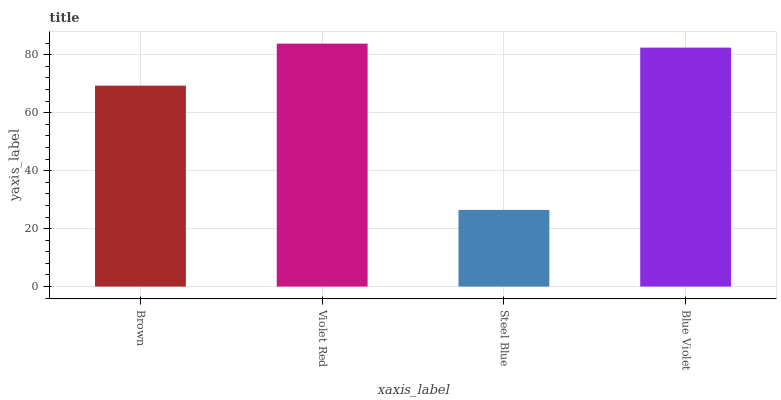Is Steel Blue the minimum?
Answer yes or no. Yes. Is Violet Red the maximum?
Answer yes or no. Yes. Is Violet Red the minimum?
Answer yes or no. No. Is Steel Blue the maximum?
Answer yes or no. No. Is Violet Red greater than Steel Blue?
Answer yes or no. Yes. Is Steel Blue less than Violet Red?
Answer yes or no. Yes. Is Steel Blue greater than Violet Red?
Answer yes or no. No. Is Violet Red less than Steel Blue?
Answer yes or no. No. Is Blue Violet the high median?
Answer yes or no. Yes. Is Brown the low median?
Answer yes or no. Yes. Is Steel Blue the high median?
Answer yes or no. No. Is Blue Violet the low median?
Answer yes or no. No. 